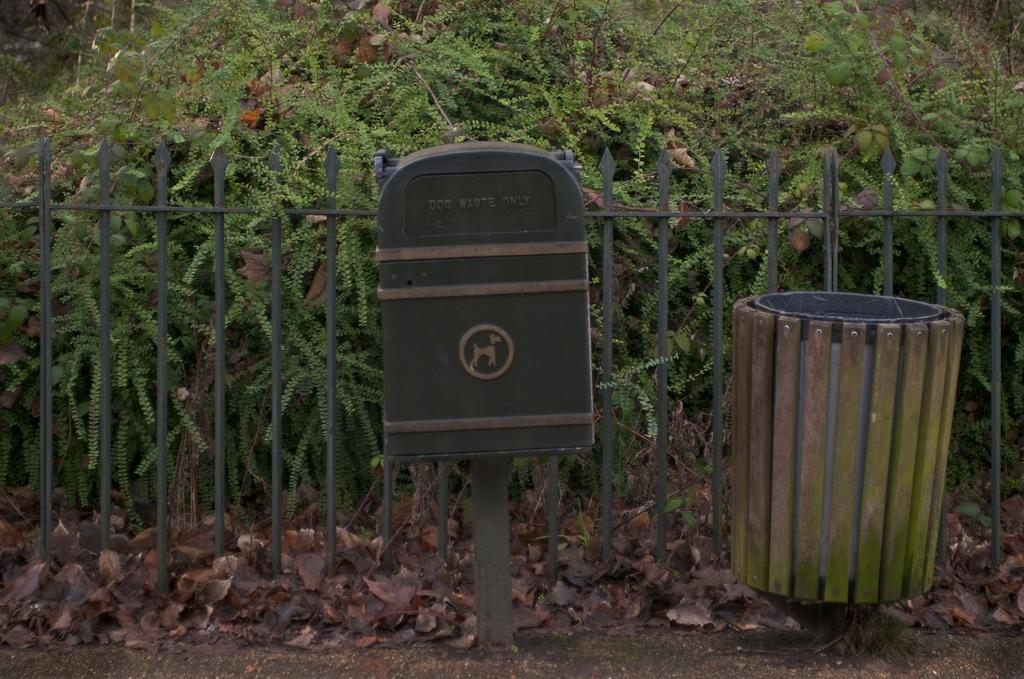<image>
Provide a brief description of the given image. A DOG WASTE ONLY container sits next to a garbage bin 